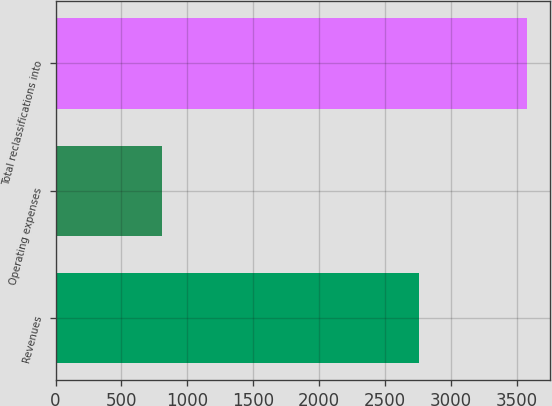<chart> <loc_0><loc_0><loc_500><loc_500><bar_chart><fcel>Revenues<fcel>Operating expenses<fcel>Total reclassifications into<nl><fcel>2759<fcel>805<fcel>3572<nl></chart> 